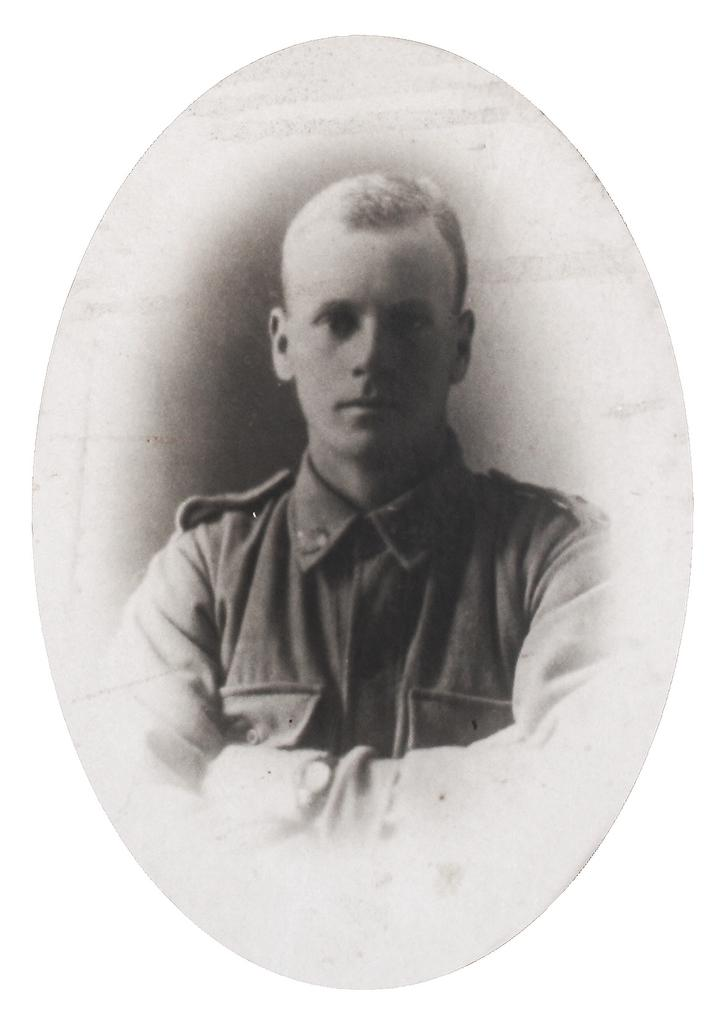What is present in the image? There is a poster in the image. What is depicted on the poster? The poster features a person. What type of fang can be seen in the image? There is no fang present in the image; it features a poster with a person. Is there any oatmeal visible in the image? There is no oatmeal present in the image. 